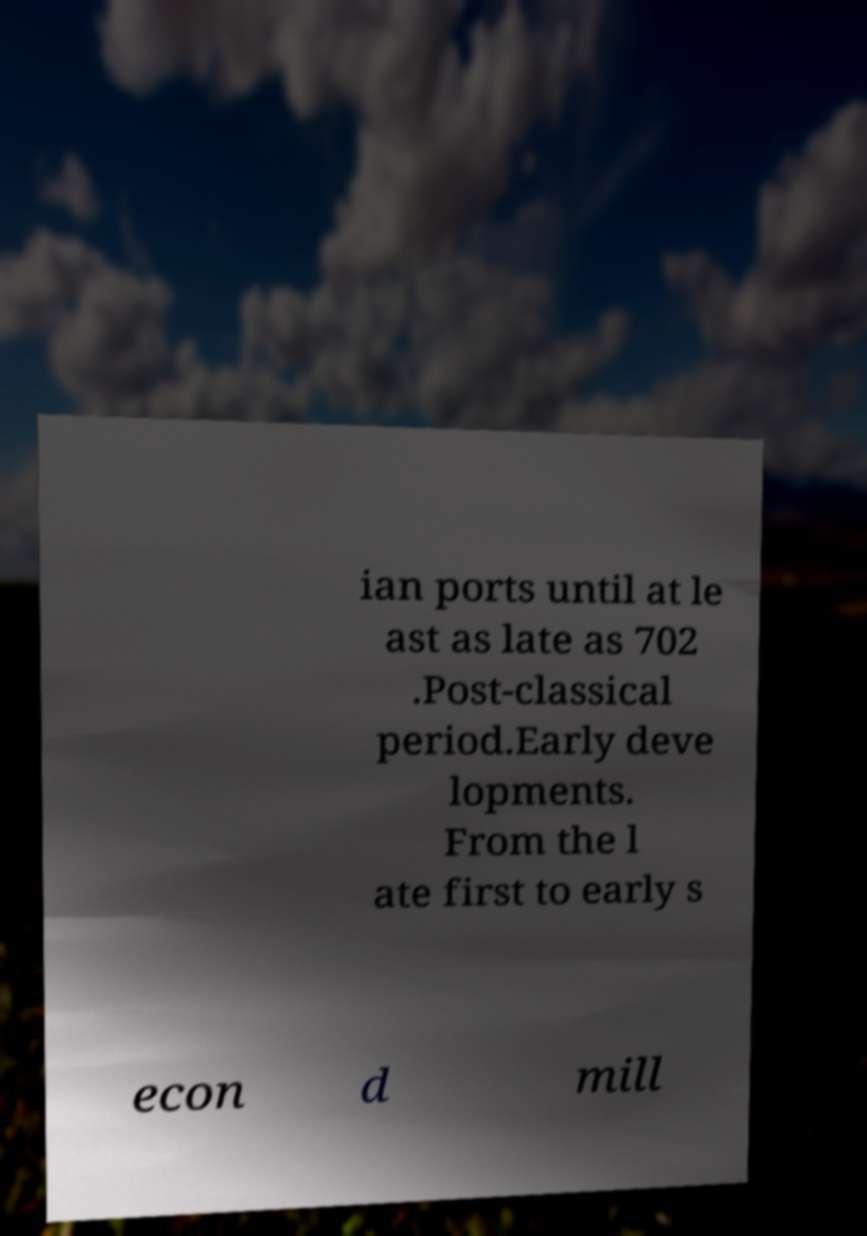There's text embedded in this image that I need extracted. Can you transcribe it verbatim? ian ports until at le ast as late as 702 .Post-classical period.Early deve lopments. From the l ate first to early s econ d mill 